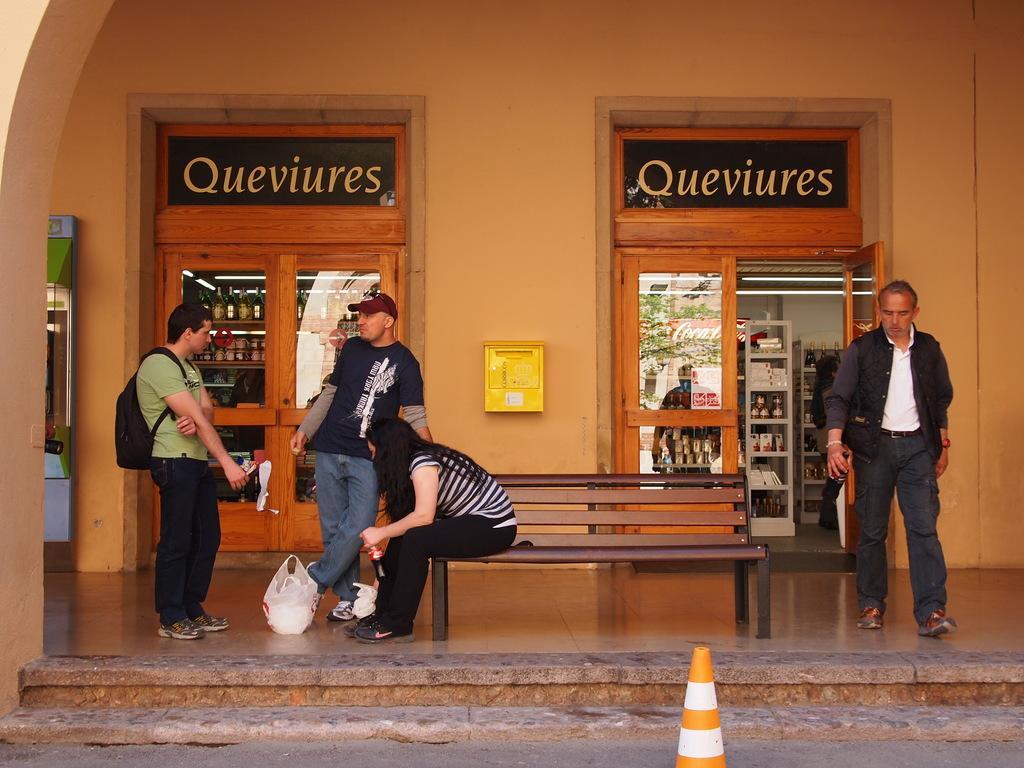Could you give a brief overview of what you see in this image? In this image we can see three men standing on the floor and a woman sitting on the bench. In additional to this we can see name boards, windows, beverage bottles arranged in rows and a traffic cone. 